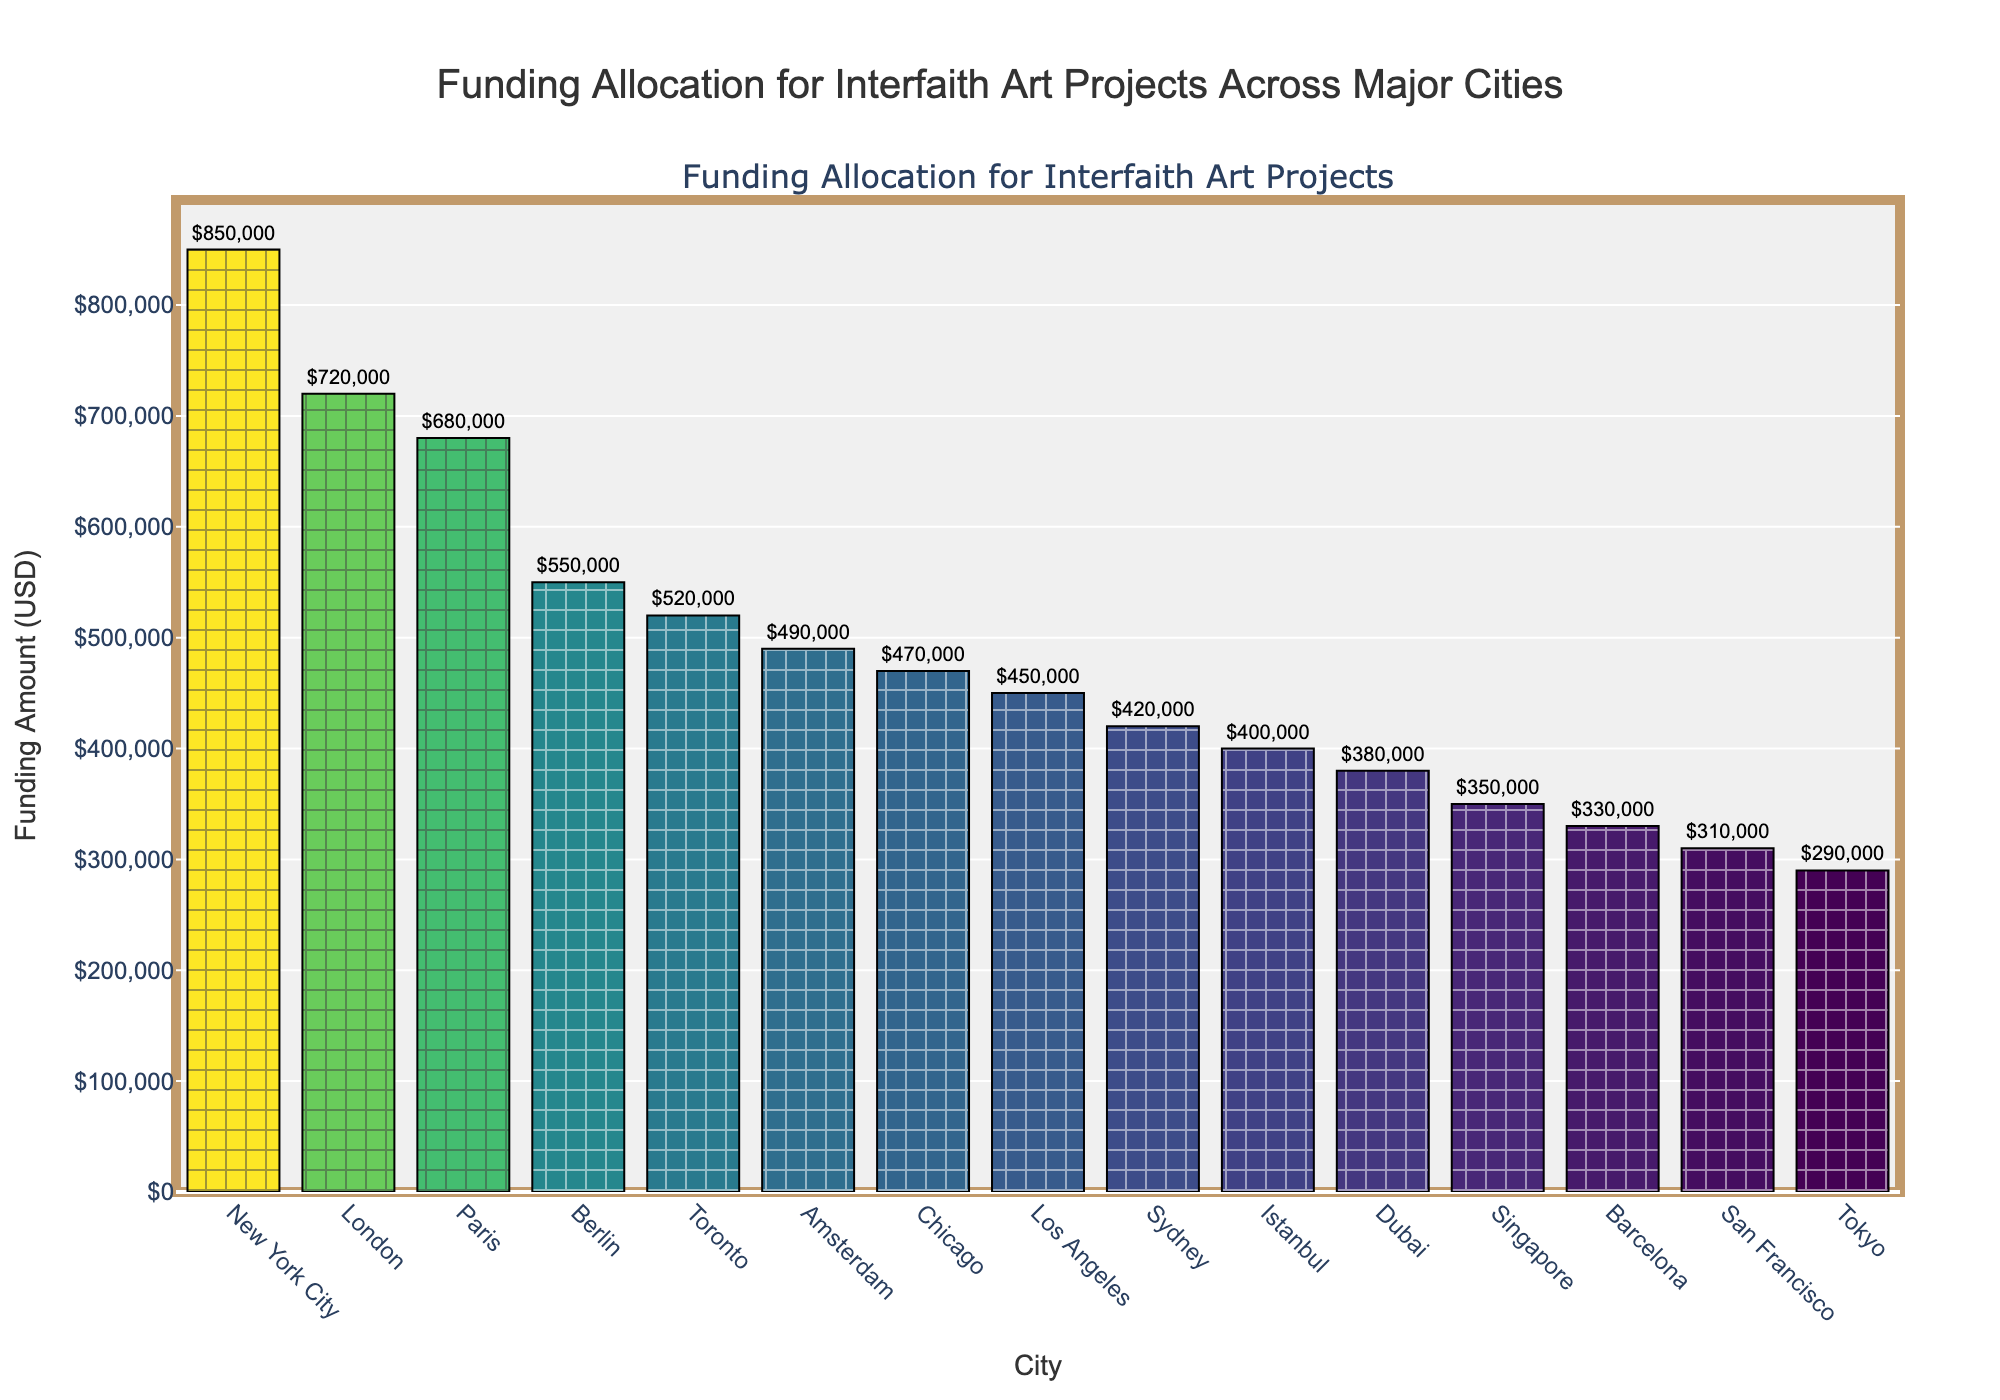What's the funding allocation for interfaith art projects in London? Look at the bar corresponding to London. The hover text or height of the bar shows the funding amount for London.
Answer: $720,000 Which city received the least funding for interfaith art projects? Find the bar with the shortest height or the smallest numerical value. The hover text or label for this bar shows the funding amount. The shortest bar belongs to Tokyo.
Answer: Tokyo What is the total funding amount allocated to New York City and London? Sum the funding amounts for New York City ($850,000) and London ($720,000).
Answer: $1,570,000 Compare the funding between New York City and Tokyo. How much more funding did New York City receive than Tokyo? Subtract the funding amount for Tokyo from that of New York City. New York City received $850,000, and Tokyo received $290,000.
Answer: $560,000 What can you infer about the distribution of funding across the major cities? Analyze the overall heights of the bars. The funding is highest for New York City and decreases as you move to the right. There's a noticeable drop after the top 3-4 cities.
Answer: Funding is highest in New York City, and generally decreases for the other cities Which city received more funding, Sydney or Los Angeles? Compare the heights of the bars for Sydney and Los Angeles. Sydney's bar is taller than Los Angeles's.
Answer: Sydney What is the average funding amount allocated across all 15 cities? Sum all the individual funding amounts and divide by the number of cities (15). Sum: $850,000 + $720,000 + $680,000 + $550,000 + $520,000 + $490,000 + $470,000 + $450,000 + $420,000 + $400,000 + $380,000 + $350,000 + $330,000 + $310,000 + $290,000 = $7,210,000. Average: $7,210,000 / 15.
Answer: $480,666.67 What is the difference in funding between the city with the highest funding and the city with the lowest funding? Subtract the funding amount for the city with the lowest funding (Tokyo, $290,000) from the highest funding (New York City, $850,000).
Answer: $560,000 What is the median funding amount for the cities? Arrange the cities in order of funding and find the middle value. The ordered funding amounts are: $290,000, $310,000, $330,000, $350,000, $380,000, $400,000, $420,000, $450,000, $470,000, $490,000, $520,000, $550,000, $680,000, $720,000, $850,000. The 8th value (middle) is $450,000.
Answer: $450,000 How does the funding for Berlin compare to that for Istanbul? Compare the heights of the bars for Berlin and Istanbul. Berlin's bar is taller, indicating higher funding. The funding for Berlin is $550,000, and for Istanbul, it's $400,000.
Answer: Berlin received $150,000 more 